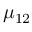<formula> <loc_0><loc_0><loc_500><loc_500>\mu _ { 1 2 }</formula> 